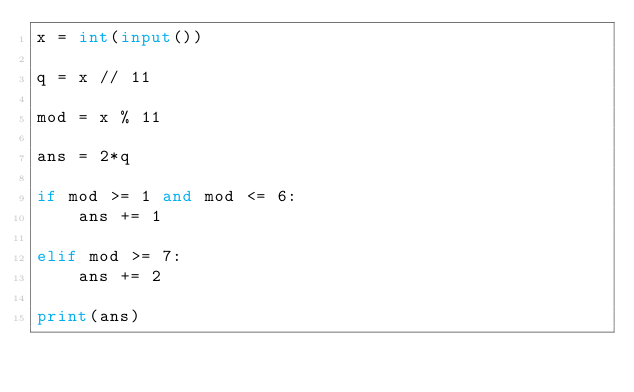<code> <loc_0><loc_0><loc_500><loc_500><_Python_>x = int(input())

q = x // 11

mod = x % 11

ans = 2*q

if mod >= 1 and mod <= 6:
    ans += 1

elif mod >= 7:
    ans += 2

print(ans)</code> 